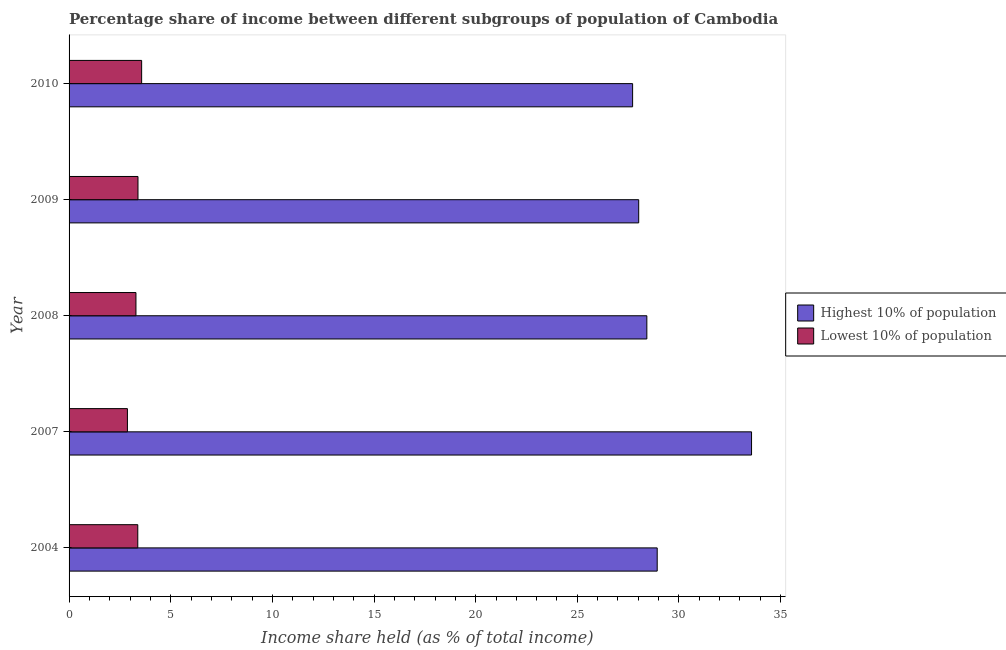How many different coloured bars are there?
Offer a very short reply. 2. How many groups of bars are there?
Give a very brief answer. 5. How many bars are there on the 4th tick from the top?
Offer a terse response. 2. How many bars are there on the 4th tick from the bottom?
Ensure brevity in your answer.  2. In how many cases, is the number of bars for a given year not equal to the number of legend labels?
Offer a terse response. 0. What is the income share held by highest 10% of the population in 2009?
Your answer should be compact. 28.02. Across all years, what is the maximum income share held by highest 10% of the population?
Make the answer very short. 33.57. Across all years, what is the minimum income share held by lowest 10% of the population?
Your response must be concise. 2.87. In which year was the income share held by highest 10% of the population maximum?
Your answer should be very brief. 2007. In which year was the income share held by highest 10% of the population minimum?
Your answer should be compact. 2010. What is the total income share held by highest 10% of the population in the graph?
Your answer should be very brief. 146.66. What is the difference between the income share held by highest 10% of the population in 2008 and that in 2009?
Offer a terse response. 0.4. What is the difference between the income share held by lowest 10% of the population in 2004 and the income share held by highest 10% of the population in 2007?
Your answer should be very brief. -30.19. What is the average income share held by lowest 10% of the population per year?
Your answer should be compact. 3.3. In the year 2004, what is the difference between the income share held by highest 10% of the population and income share held by lowest 10% of the population?
Keep it short and to the point. 25.55. In how many years, is the income share held by lowest 10% of the population greater than 30 %?
Give a very brief answer. 0. What is the ratio of the income share held by highest 10% of the population in 2007 to that in 2009?
Offer a very short reply. 1.2. What is the difference between the highest and the second highest income share held by lowest 10% of the population?
Your answer should be very brief. 0.18. What is the difference between the highest and the lowest income share held by highest 10% of the population?
Give a very brief answer. 5.85. Is the sum of the income share held by lowest 10% of the population in 2009 and 2010 greater than the maximum income share held by highest 10% of the population across all years?
Give a very brief answer. No. What does the 2nd bar from the top in 2008 represents?
Your answer should be very brief. Highest 10% of population. What does the 1st bar from the bottom in 2009 represents?
Your answer should be compact. Highest 10% of population. How many years are there in the graph?
Offer a terse response. 5. What is the difference between two consecutive major ticks on the X-axis?
Make the answer very short. 5. Are the values on the major ticks of X-axis written in scientific E-notation?
Ensure brevity in your answer.  No. Does the graph contain any zero values?
Make the answer very short. No. Where does the legend appear in the graph?
Provide a short and direct response. Center right. What is the title of the graph?
Make the answer very short. Percentage share of income between different subgroups of population of Cambodia. Does "Health Care" appear as one of the legend labels in the graph?
Offer a very short reply. No. What is the label or title of the X-axis?
Ensure brevity in your answer.  Income share held (as % of total income). What is the Income share held (as % of total income) of Highest 10% of population in 2004?
Offer a terse response. 28.93. What is the Income share held (as % of total income) of Lowest 10% of population in 2004?
Keep it short and to the point. 3.38. What is the Income share held (as % of total income) of Highest 10% of population in 2007?
Give a very brief answer. 33.57. What is the Income share held (as % of total income) in Lowest 10% of population in 2007?
Offer a very short reply. 2.87. What is the Income share held (as % of total income) of Highest 10% of population in 2008?
Keep it short and to the point. 28.42. What is the Income share held (as % of total income) in Lowest 10% of population in 2008?
Provide a short and direct response. 3.29. What is the Income share held (as % of total income) of Highest 10% of population in 2009?
Your response must be concise. 28.02. What is the Income share held (as % of total income) in Lowest 10% of population in 2009?
Ensure brevity in your answer.  3.39. What is the Income share held (as % of total income) of Highest 10% of population in 2010?
Your answer should be very brief. 27.72. What is the Income share held (as % of total income) of Lowest 10% of population in 2010?
Give a very brief answer. 3.57. Across all years, what is the maximum Income share held (as % of total income) in Highest 10% of population?
Ensure brevity in your answer.  33.57. Across all years, what is the maximum Income share held (as % of total income) in Lowest 10% of population?
Offer a very short reply. 3.57. Across all years, what is the minimum Income share held (as % of total income) of Highest 10% of population?
Ensure brevity in your answer.  27.72. Across all years, what is the minimum Income share held (as % of total income) in Lowest 10% of population?
Offer a very short reply. 2.87. What is the total Income share held (as % of total income) of Highest 10% of population in the graph?
Offer a terse response. 146.66. What is the difference between the Income share held (as % of total income) of Highest 10% of population in 2004 and that in 2007?
Ensure brevity in your answer.  -4.64. What is the difference between the Income share held (as % of total income) in Lowest 10% of population in 2004 and that in 2007?
Keep it short and to the point. 0.51. What is the difference between the Income share held (as % of total income) of Highest 10% of population in 2004 and that in 2008?
Your response must be concise. 0.51. What is the difference between the Income share held (as % of total income) of Lowest 10% of population in 2004 and that in 2008?
Give a very brief answer. 0.09. What is the difference between the Income share held (as % of total income) in Highest 10% of population in 2004 and that in 2009?
Your answer should be very brief. 0.91. What is the difference between the Income share held (as % of total income) of Lowest 10% of population in 2004 and that in 2009?
Give a very brief answer. -0.01. What is the difference between the Income share held (as % of total income) of Highest 10% of population in 2004 and that in 2010?
Ensure brevity in your answer.  1.21. What is the difference between the Income share held (as % of total income) of Lowest 10% of population in 2004 and that in 2010?
Make the answer very short. -0.19. What is the difference between the Income share held (as % of total income) in Highest 10% of population in 2007 and that in 2008?
Give a very brief answer. 5.15. What is the difference between the Income share held (as % of total income) of Lowest 10% of population in 2007 and that in 2008?
Provide a short and direct response. -0.42. What is the difference between the Income share held (as % of total income) of Highest 10% of population in 2007 and that in 2009?
Keep it short and to the point. 5.55. What is the difference between the Income share held (as % of total income) of Lowest 10% of population in 2007 and that in 2009?
Your answer should be very brief. -0.52. What is the difference between the Income share held (as % of total income) of Highest 10% of population in 2007 and that in 2010?
Offer a very short reply. 5.85. What is the difference between the Income share held (as % of total income) of Lowest 10% of population in 2007 and that in 2010?
Your answer should be very brief. -0.7. What is the difference between the Income share held (as % of total income) of Highest 10% of population in 2008 and that in 2009?
Give a very brief answer. 0.4. What is the difference between the Income share held (as % of total income) in Lowest 10% of population in 2008 and that in 2009?
Your answer should be very brief. -0.1. What is the difference between the Income share held (as % of total income) of Lowest 10% of population in 2008 and that in 2010?
Offer a terse response. -0.28. What is the difference between the Income share held (as % of total income) of Lowest 10% of population in 2009 and that in 2010?
Your response must be concise. -0.18. What is the difference between the Income share held (as % of total income) in Highest 10% of population in 2004 and the Income share held (as % of total income) in Lowest 10% of population in 2007?
Make the answer very short. 26.06. What is the difference between the Income share held (as % of total income) in Highest 10% of population in 2004 and the Income share held (as % of total income) in Lowest 10% of population in 2008?
Give a very brief answer. 25.64. What is the difference between the Income share held (as % of total income) in Highest 10% of population in 2004 and the Income share held (as % of total income) in Lowest 10% of population in 2009?
Keep it short and to the point. 25.54. What is the difference between the Income share held (as % of total income) of Highest 10% of population in 2004 and the Income share held (as % of total income) of Lowest 10% of population in 2010?
Give a very brief answer. 25.36. What is the difference between the Income share held (as % of total income) in Highest 10% of population in 2007 and the Income share held (as % of total income) in Lowest 10% of population in 2008?
Give a very brief answer. 30.28. What is the difference between the Income share held (as % of total income) of Highest 10% of population in 2007 and the Income share held (as % of total income) of Lowest 10% of population in 2009?
Offer a terse response. 30.18. What is the difference between the Income share held (as % of total income) of Highest 10% of population in 2008 and the Income share held (as % of total income) of Lowest 10% of population in 2009?
Offer a terse response. 25.03. What is the difference between the Income share held (as % of total income) in Highest 10% of population in 2008 and the Income share held (as % of total income) in Lowest 10% of population in 2010?
Make the answer very short. 24.85. What is the difference between the Income share held (as % of total income) of Highest 10% of population in 2009 and the Income share held (as % of total income) of Lowest 10% of population in 2010?
Make the answer very short. 24.45. What is the average Income share held (as % of total income) in Highest 10% of population per year?
Your response must be concise. 29.33. What is the average Income share held (as % of total income) in Lowest 10% of population per year?
Your answer should be very brief. 3.3. In the year 2004, what is the difference between the Income share held (as % of total income) of Highest 10% of population and Income share held (as % of total income) of Lowest 10% of population?
Your answer should be compact. 25.55. In the year 2007, what is the difference between the Income share held (as % of total income) in Highest 10% of population and Income share held (as % of total income) in Lowest 10% of population?
Make the answer very short. 30.7. In the year 2008, what is the difference between the Income share held (as % of total income) in Highest 10% of population and Income share held (as % of total income) in Lowest 10% of population?
Offer a very short reply. 25.13. In the year 2009, what is the difference between the Income share held (as % of total income) in Highest 10% of population and Income share held (as % of total income) in Lowest 10% of population?
Offer a very short reply. 24.63. In the year 2010, what is the difference between the Income share held (as % of total income) of Highest 10% of population and Income share held (as % of total income) of Lowest 10% of population?
Offer a terse response. 24.15. What is the ratio of the Income share held (as % of total income) of Highest 10% of population in 2004 to that in 2007?
Provide a short and direct response. 0.86. What is the ratio of the Income share held (as % of total income) in Lowest 10% of population in 2004 to that in 2007?
Your answer should be very brief. 1.18. What is the ratio of the Income share held (as % of total income) in Highest 10% of population in 2004 to that in 2008?
Make the answer very short. 1.02. What is the ratio of the Income share held (as % of total income) of Lowest 10% of population in 2004 to that in 2008?
Your response must be concise. 1.03. What is the ratio of the Income share held (as % of total income) of Highest 10% of population in 2004 to that in 2009?
Your answer should be very brief. 1.03. What is the ratio of the Income share held (as % of total income) in Highest 10% of population in 2004 to that in 2010?
Offer a very short reply. 1.04. What is the ratio of the Income share held (as % of total income) in Lowest 10% of population in 2004 to that in 2010?
Give a very brief answer. 0.95. What is the ratio of the Income share held (as % of total income) in Highest 10% of population in 2007 to that in 2008?
Provide a short and direct response. 1.18. What is the ratio of the Income share held (as % of total income) in Lowest 10% of population in 2007 to that in 2008?
Offer a very short reply. 0.87. What is the ratio of the Income share held (as % of total income) in Highest 10% of population in 2007 to that in 2009?
Provide a short and direct response. 1.2. What is the ratio of the Income share held (as % of total income) in Lowest 10% of population in 2007 to that in 2009?
Provide a succinct answer. 0.85. What is the ratio of the Income share held (as % of total income) in Highest 10% of population in 2007 to that in 2010?
Ensure brevity in your answer.  1.21. What is the ratio of the Income share held (as % of total income) of Lowest 10% of population in 2007 to that in 2010?
Ensure brevity in your answer.  0.8. What is the ratio of the Income share held (as % of total income) in Highest 10% of population in 2008 to that in 2009?
Your answer should be very brief. 1.01. What is the ratio of the Income share held (as % of total income) in Lowest 10% of population in 2008 to that in 2009?
Offer a terse response. 0.97. What is the ratio of the Income share held (as % of total income) in Highest 10% of population in 2008 to that in 2010?
Give a very brief answer. 1.03. What is the ratio of the Income share held (as % of total income) in Lowest 10% of population in 2008 to that in 2010?
Make the answer very short. 0.92. What is the ratio of the Income share held (as % of total income) of Highest 10% of population in 2009 to that in 2010?
Provide a succinct answer. 1.01. What is the ratio of the Income share held (as % of total income) of Lowest 10% of population in 2009 to that in 2010?
Your answer should be very brief. 0.95. What is the difference between the highest and the second highest Income share held (as % of total income) of Highest 10% of population?
Make the answer very short. 4.64. What is the difference between the highest and the second highest Income share held (as % of total income) in Lowest 10% of population?
Your response must be concise. 0.18. What is the difference between the highest and the lowest Income share held (as % of total income) of Highest 10% of population?
Offer a terse response. 5.85. What is the difference between the highest and the lowest Income share held (as % of total income) of Lowest 10% of population?
Ensure brevity in your answer.  0.7. 